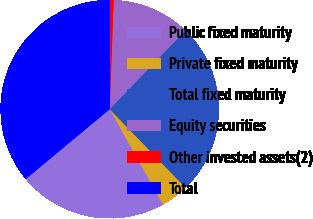Convert chart to OTSL. <chart><loc_0><loc_0><loc_500><loc_500><pie_chart><fcel>Public fixed maturity<fcel>Private fixed maturity<fcel>Total fixed maturity<fcel>Equity securities<fcel>Other invested assets(2)<fcel>Total<nl><fcel>22.06%<fcel>4.11%<fcel>25.61%<fcel>11.61%<fcel>0.56%<fcel>36.07%<nl></chart> 